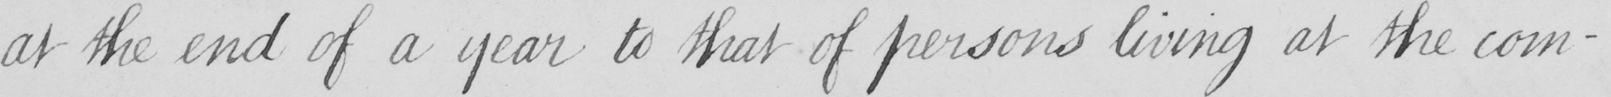Can you tell me what this handwritten text says? at the end of a year to that of persons living at the com- 